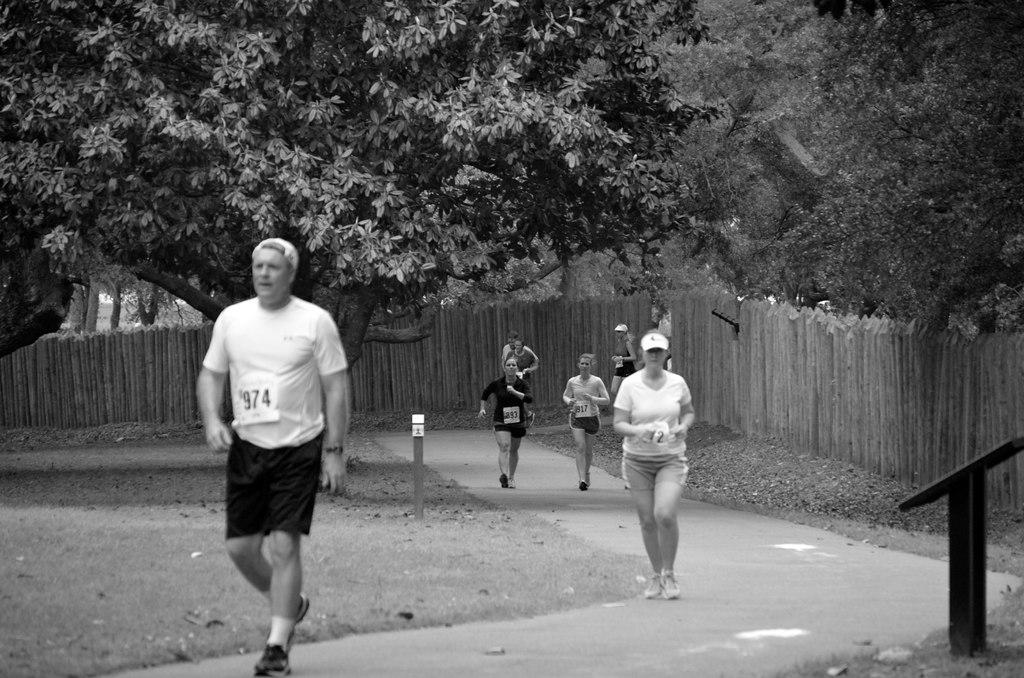What activity are the people in the image engaged in? The people in the image are jogging. On what surface are the people jogging? The people are jogging on the road. What can be seen in the background of the image? There are trees visible in the background of the image. What type of locket can be seen hanging from the trees in the background? There is no locket present in the image, and therefore no such object can be observed hanging from the trees. Can you hear the people jogging in the image? The image is a still picture, so it does not have any sound or audio. 